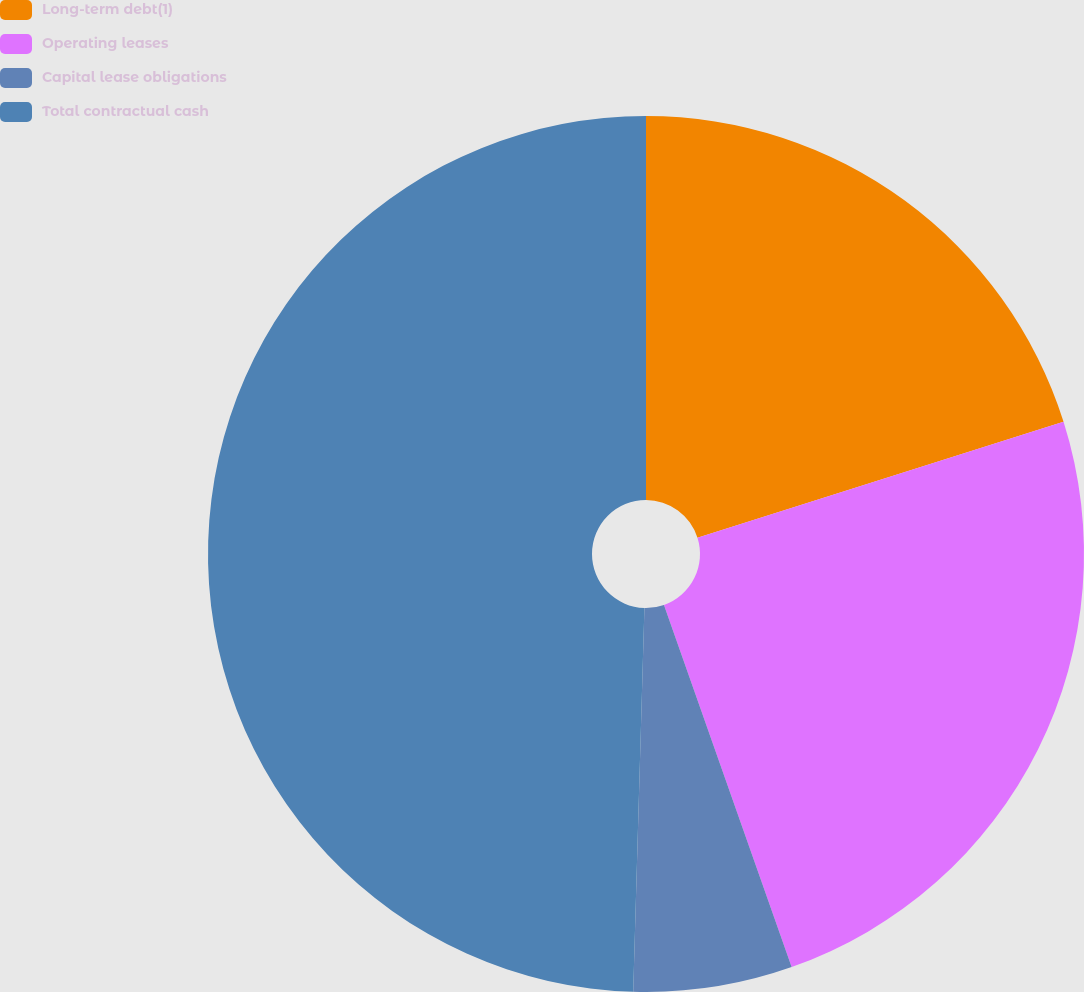Convert chart. <chart><loc_0><loc_0><loc_500><loc_500><pie_chart><fcel>Long-term debt(1)<fcel>Operating leases<fcel>Capital lease obligations<fcel>Total contractual cash<nl><fcel>20.12%<fcel>24.49%<fcel>5.86%<fcel>49.54%<nl></chart> 